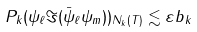<formula> <loc_0><loc_0><loc_500><loc_500>\| P _ { k } ( \psi _ { \ell } \Im ( \bar { \psi } _ { \ell } \psi _ { m } ) ) \| _ { N _ { k } ( T ) } \lesssim \varepsilon b _ { k }</formula> 